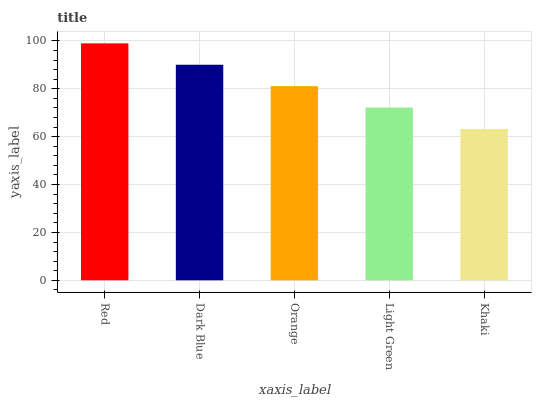Is Dark Blue the minimum?
Answer yes or no. No. Is Dark Blue the maximum?
Answer yes or no. No. Is Red greater than Dark Blue?
Answer yes or no. Yes. Is Dark Blue less than Red?
Answer yes or no. Yes. Is Dark Blue greater than Red?
Answer yes or no. No. Is Red less than Dark Blue?
Answer yes or no. No. Is Orange the high median?
Answer yes or no. Yes. Is Orange the low median?
Answer yes or no. Yes. Is Light Green the high median?
Answer yes or no. No. Is Light Green the low median?
Answer yes or no. No. 